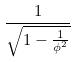Convert formula to latex. <formula><loc_0><loc_0><loc_500><loc_500>\frac { 1 } { \sqrt { 1 - \frac { 1 } { \phi ^ { 2 } } } }</formula> 